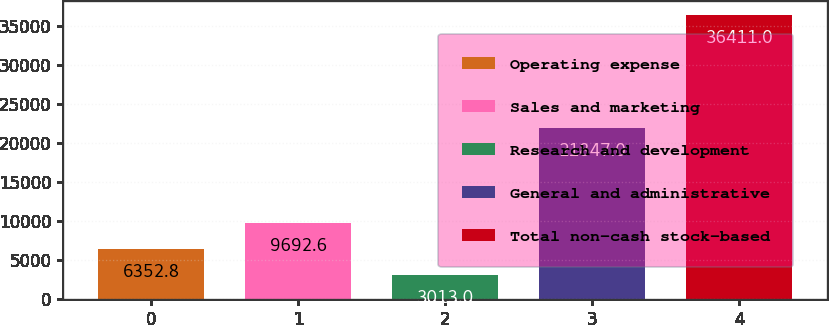<chart> <loc_0><loc_0><loc_500><loc_500><bar_chart><fcel>Operating expense<fcel>Sales and marketing<fcel>Research and development<fcel>General and administrative<fcel>Total non-cash stock-based<nl><fcel>6352.8<fcel>9692.6<fcel>3013<fcel>21847<fcel>36411<nl></chart> 